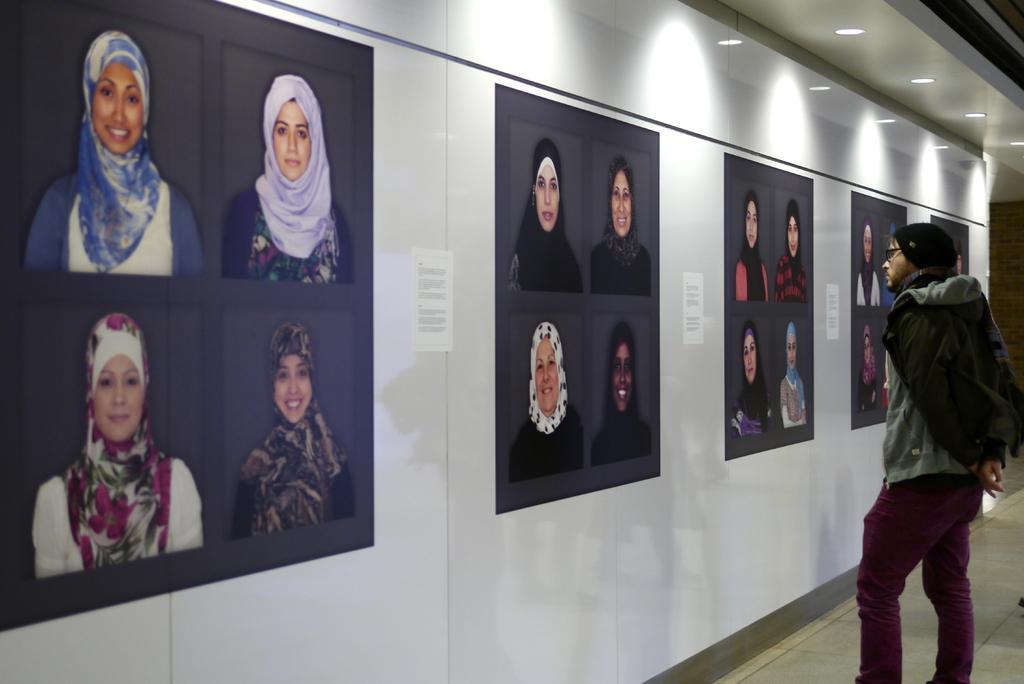Please provide a concise description of this image. In the foreground of this image, there is a man standing near a wall to which few posts are posted on it. On the top, we can see few lights. 